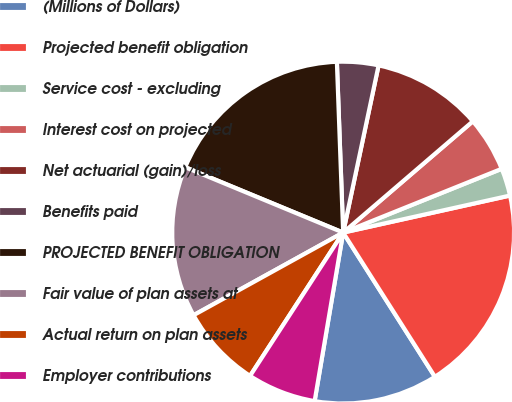Convert chart. <chart><loc_0><loc_0><loc_500><loc_500><pie_chart><fcel>(Millions of Dollars)<fcel>Projected benefit obligation<fcel>Service cost - excluding<fcel>Interest cost on projected<fcel>Net actuarial (gain)/loss<fcel>Benefits paid<fcel>PROJECTED BENEFIT OBLIGATION<fcel>Fair value of plan assets at<fcel>Actual return on plan assets<fcel>Employer contributions<nl><fcel>11.69%<fcel>19.46%<fcel>2.61%<fcel>5.2%<fcel>10.39%<fcel>3.91%<fcel>18.17%<fcel>14.28%<fcel>7.8%<fcel>6.5%<nl></chart> 